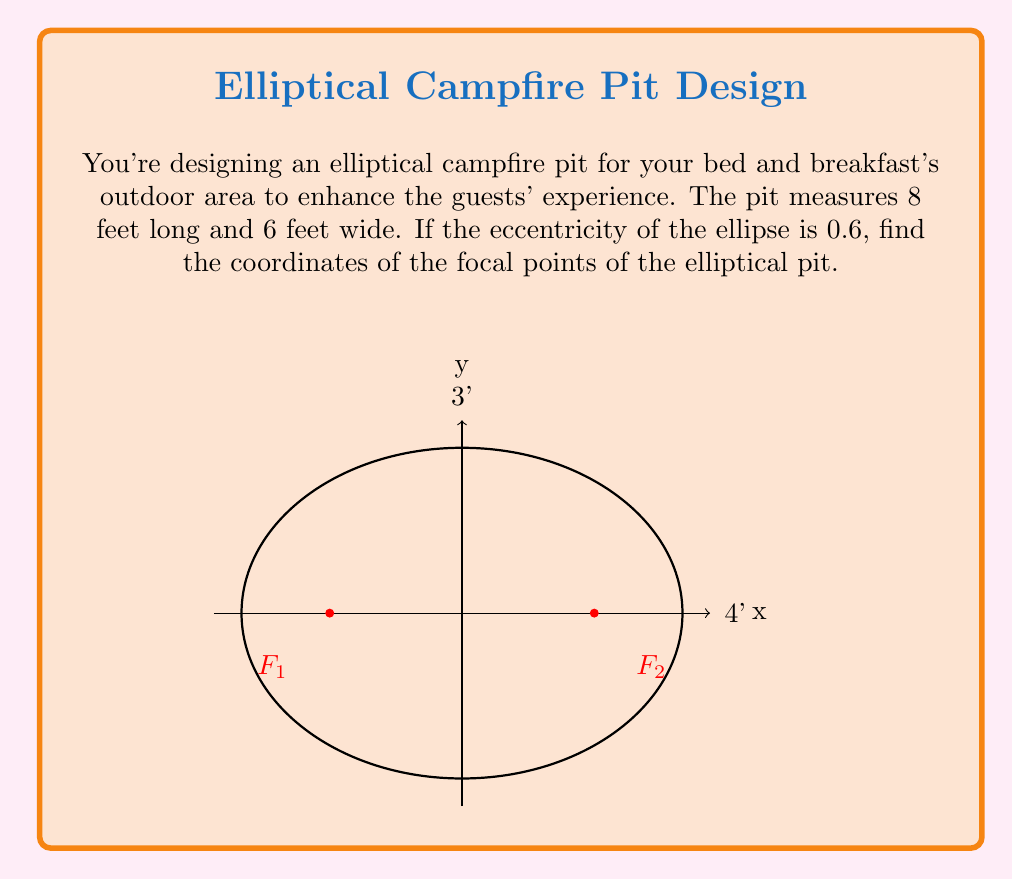Can you solve this math problem? Let's approach this step-by-step:

1) The equation of an ellipse is given by $\frac{x^2}{a^2} + \frac{y^2}{b^2} = 1$, where $a$ is the semi-major axis and $b$ is the semi-minor axis.

2) Given dimensions: length = 8 feet, width = 6 feet
   So, $a = 4$ feet (half of the length) and $b = 3$ feet (half of the width)

3) The eccentricity $e$ is given as 0.6

4) The relationship between $a$, $b$, and $e$ is:

   $$e = \sqrt{1 - \frac{b^2}{a^2}}$$

5) We can verify this:
   $$0.6 = \sqrt{1 - \frac{3^2}{4^2}} = \sqrt{1 - \frac{9}{16}} = \sqrt{\frac{7}{16}} \approx 0.6$$

6) The distance $c$ from the center to a focus is given by:
   
   $$c = ae$$

7) Calculating $c$:
   $$c = 4 * 0.6 = 2.4$$ feet

8) The focal points are located at $(±c, 0)$ on the x-axis

Therefore, the focal points are at $(-2.4, 0)$ and $(2.4, 0)$ feet from the center of the ellipse.
Answer: $(-2.4, 0)$ and $(2.4, 0)$ feet 